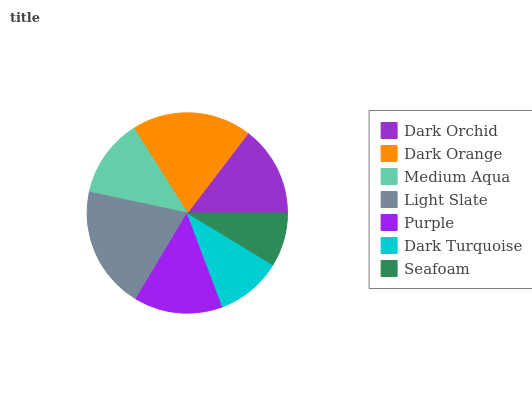Is Seafoam the minimum?
Answer yes or no. Yes. Is Light Slate the maximum?
Answer yes or no. Yes. Is Dark Orange the minimum?
Answer yes or no. No. Is Dark Orange the maximum?
Answer yes or no. No. Is Dark Orange greater than Dark Orchid?
Answer yes or no. Yes. Is Dark Orchid less than Dark Orange?
Answer yes or no. Yes. Is Dark Orchid greater than Dark Orange?
Answer yes or no. No. Is Dark Orange less than Dark Orchid?
Answer yes or no. No. Is Purple the high median?
Answer yes or no. Yes. Is Purple the low median?
Answer yes or no. Yes. Is Seafoam the high median?
Answer yes or no. No. Is Light Slate the low median?
Answer yes or no. No. 